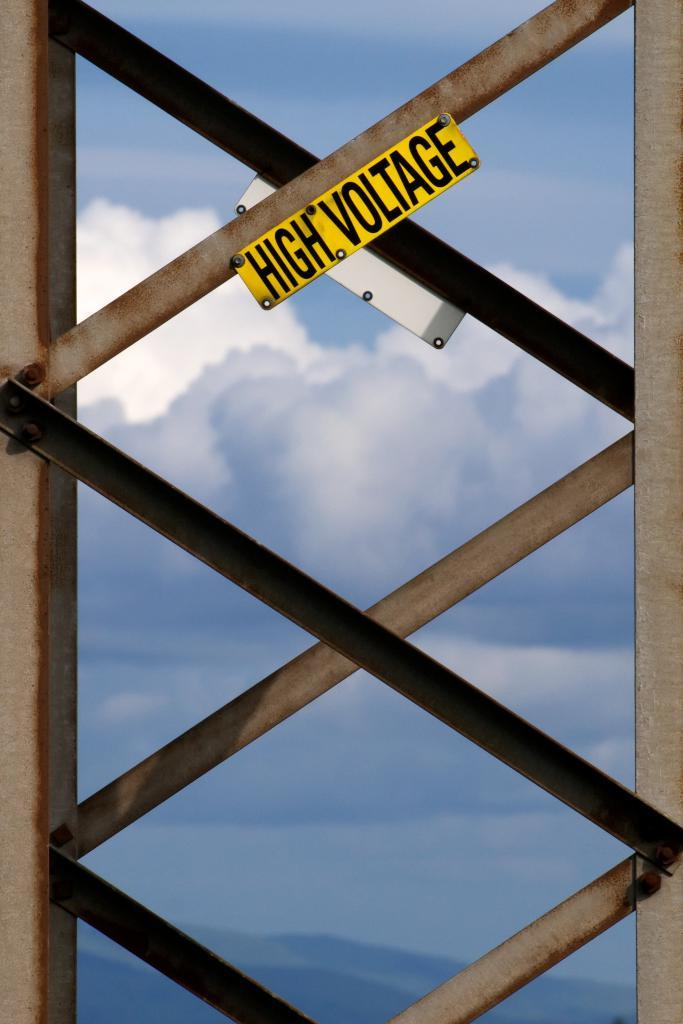What objects are present in the image? There are iron rods in the image. What is attached to the iron rods? Warning boards are fixed to the iron rods. What can be seen in the background of the image? There is sky visible in the background of the image. What is the name of the car parked near the iron rods in the image? There is no car present in the image, so it is not possible to determine the name of a car. 